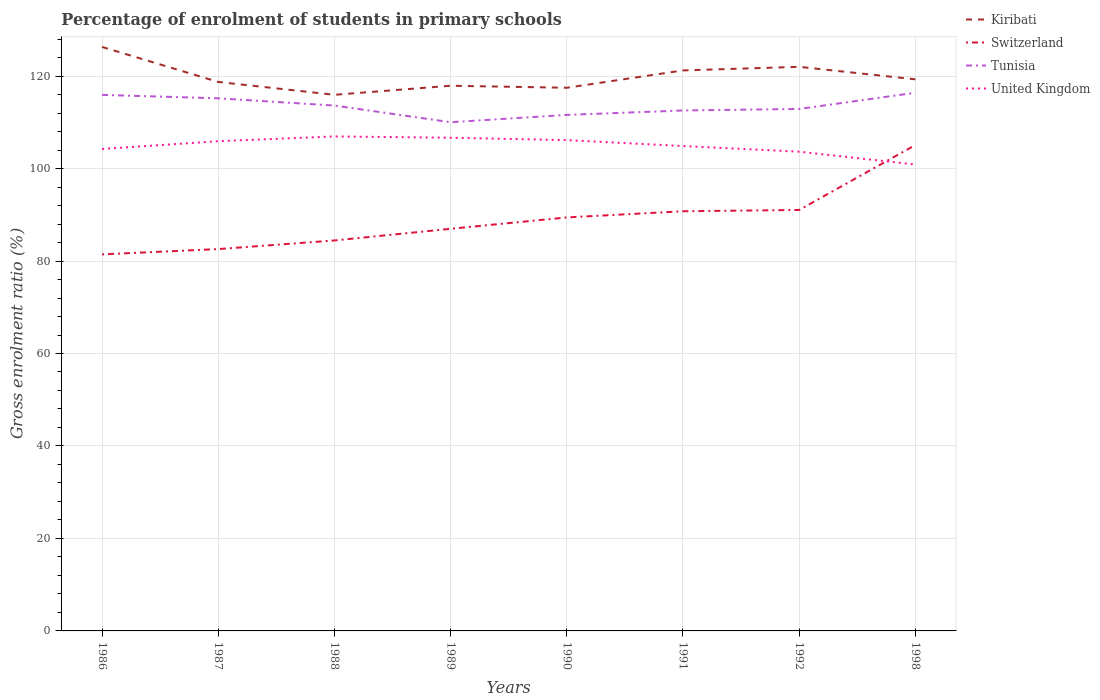Does the line corresponding to Kiribati intersect with the line corresponding to United Kingdom?
Offer a terse response. No. Is the number of lines equal to the number of legend labels?
Offer a terse response. Yes. Across all years, what is the maximum percentage of students enrolled in primary schools in United Kingdom?
Offer a terse response. 100.87. What is the total percentage of students enrolled in primary schools in Tunisia in the graph?
Your answer should be very brief. 5.91. What is the difference between the highest and the second highest percentage of students enrolled in primary schools in United Kingdom?
Ensure brevity in your answer.  6.07. How many years are there in the graph?
Keep it short and to the point. 8. What is the difference between two consecutive major ticks on the Y-axis?
Offer a terse response. 20. Are the values on the major ticks of Y-axis written in scientific E-notation?
Make the answer very short. No. Does the graph contain any zero values?
Your answer should be compact. No. Does the graph contain grids?
Provide a succinct answer. Yes. How are the legend labels stacked?
Give a very brief answer. Vertical. What is the title of the graph?
Your response must be concise. Percentage of enrolment of students in primary schools. What is the label or title of the X-axis?
Offer a very short reply. Years. What is the label or title of the Y-axis?
Your response must be concise. Gross enrolment ratio (%). What is the Gross enrolment ratio (%) of Kiribati in 1986?
Give a very brief answer. 126.3. What is the Gross enrolment ratio (%) of Switzerland in 1986?
Offer a very short reply. 81.44. What is the Gross enrolment ratio (%) of Tunisia in 1986?
Ensure brevity in your answer.  115.93. What is the Gross enrolment ratio (%) of United Kingdom in 1986?
Ensure brevity in your answer.  104.23. What is the Gross enrolment ratio (%) of Kiribati in 1987?
Your answer should be very brief. 118.73. What is the Gross enrolment ratio (%) in Switzerland in 1987?
Make the answer very short. 82.58. What is the Gross enrolment ratio (%) of Tunisia in 1987?
Ensure brevity in your answer.  115.19. What is the Gross enrolment ratio (%) of United Kingdom in 1987?
Provide a short and direct response. 105.91. What is the Gross enrolment ratio (%) of Kiribati in 1988?
Your response must be concise. 115.95. What is the Gross enrolment ratio (%) of Switzerland in 1988?
Your answer should be compact. 84.45. What is the Gross enrolment ratio (%) in Tunisia in 1988?
Keep it short and to the point. 113.62. What is the Gross enrolment ratio (%) of United Kingdom in 1988?
Offer a terse response. 106.94. What is the Gross enrolment ratio (%) in Kiribati in 1989?
Ensure brevity in your answer.  117.91. What is the Gross enrolment ratio (%) of Switzerland in 1989?
Offer a terse response. 86.97. What is the Gross enrolment ratio (%) in Tunisia in 1989?
Provide a short and direct response. 110.02. What is the Gross enrolment ratio (%) in United Kingdom in 1989?
Provide a short and direct response. 106.67. What is the Gross enrolment ratio (%) in Kiribati in 1990?
Your response must be concise. 117.47. What is the Gross enrolment ratio (%) in Switzerland in 1990?
Give a very brief answer. 89.43. What is the Gross enrolment ratio (%) of Tunisia in 1990?
Offer a terse response. 111.6. What is the Gross enrolment ratio (%) in United Kingdom in 1990?
Provide a succinct answer. 106.15. What is the Gross enrolment ratio (%) of Kiribati in 1991?
Your answer should be compact. 121.22. What is the Gross enrolment ratio (%) of Switzerland in 1991?
Your answer should be very brief. 90.76. What is the Gross enrolment ratio (%) of Tunisia in 1991?
Provide a short and direct response. 112.56. What is the Gross enrolment ratio (%) in United Kingdom in 1991?
Give a very brief answer. 104.87. What is the Gross enrolment ratio (%) in Kiribati in 1992?
Give a very brief answer. 122. What is the Gross enrolment ratio (%) of Switzerland in 1992?
Provide a short and direct response. 91.04. What is the Gross enrolment ratio (%) in Tunisia in 1992?
Provide a short and direct response. 112.89. What is the Gross enrolment ratio (%) of United Kingdom in 1992?
Ensure brevity in your answer.  103.65. What is the Gross enrolment ratio (%) of Kiribati in 1998?
Ensure brevity in your answer.  119.3. What is the Gross enrolment ratio (%) of Switzerland in 1998?
Your response must be concise. 105.09. What is the Gross enrolment ratio (%) in Tunisia in 1998?
Ensure brevity in your answer.  116.39. What is the Gross enrolment ratio (%) in United Kingdom in 1998?
Ensure brevity in your answer.  100.87. Across all years, what is the maximum Gross enrolment ratio (%) of Kiribati?
Your answer should be very brief. 126.3. Across all years, what is the maximum Gross enrolment ratio (%) in Switzerland?
Ensure brevity in your answer.  105.09. Across all years, what is the maximum Gross enrolment ratio (%) in Tunisia?
Ensure brevity in your answer.  116.39. Across all years, what is the maximum Gross enrolment ratio (%) of United Kingdom?
Your answer should be compact. 106.94. Across all years, what is the minimum Gross enrolment ratio (%) of Kiribati?
Make the answer very short. 115.95. Across all years, what is the minimum Gross enrolment ratio (%) of Switzerland?
Make the answer very short. 81.44. Across all years, what is the minimum Gross enrolment ratio (%) in Tunisia?
Keep it short and to the point. 110.02. Across all years, what is the minimum Gross enrolment ratio (%) of United Kingdom?
Your response must be concise. 100.87. What is the total Gross enrolment ratio (%) in Kiribati in the graph?
Keep it short and to the point. 958.88. What is the total Gross enrolment ratio (%) of Switzerland in the graph?
Provide a short and direct response. 711.76. What is the total Gross enrolment ratio (%) in Tunisia in the graph?
Your answer should be very brief. 908.21. What is the total Gross enrolment ratio (%) in United Kingdom in the graph?
Your answer should be compact. 839.3. What is the difference between the Gross enrolment ratio (%) of Kiribati in 1986 and that in 1987?
Your answer should be compact. 7.57. What is the difference between the Gross enrolment ratio (%) in Switzerland in 1986 and that in 1987?
Keep it short and to the point. -1.15. What is the difference between the Gross enrolment ratio (%) in Tunisia in 1986 and that in 1987?
Provide a short and direct response. 0.74. What is the difference between the Gross enrolment ratio (%) in United Kingdom in 1986 and that in 1987?
Offer a terse response. -1.68. What is the difference between the Gross enrolment ratio (%) in Kiribati in 1986 and that in 1988?
Offer a very short reply. 10.35. What is the difference between the Gross enrolment ratio (%) in Switzerland in 1986 and that in 1988?
Make the answer very short. -3.01. What is the difference between the Gross enrolment ratio (%) of Tunisia in 1986 and that in 1988?
Provide a short and direct response. 2.31. What is the difference between the Gross enrolment ratio (%) in United Kingdom in 1986 and that in 1988?
Provide a short and direct response. -2.71. What is the difference between the Gross enrolment ratio (%) in Kiribati in 1986 and that in 1989?
Keep it short and to the point. 8.39. What is the difference between the Gross enrolment ratio (%) of Switzerland in 1986 and that in 1989?
Provide a short and direct response. -5.53. What is the difference between the Gross enrolment ratio (%) of Tunisia in 1986 and that in 1989?
Your answer should be very brief. 5.91. What is the difference between the Gross enrolment ratio (%) of United Kingdom in 1986 and that in 1989?
Provide a short and direct response. -2.43. What is the difference between the Gross enrolment ratio (%) in Kiribati in 1986 and that in 1990?
Your response must be concise. 8.83. What is the difference between the Gross enrolment ratio (%) of Switzerland in 1986 and that in 1990?
Your answer should be compact. -7.99. What is the difference between the Gross enrolment ratio (%) of Tunisia in 1986 and that in 1990?
Your answer should be very brief. 4.33. What is the difference between the Gross enrolment ratio (%) in United Kingdom in 1986 and that in 1990?
Your answer should be compact. -1.92. What is the difference between the Gross enrolment ratio (%) of Kiribati in 1986 and that in 1991?
Give a very brief answer. 5.08. What is the difference between the Gross enrolment ratio (%) in Switzerland in 1986 and that in 1991?
Offer a very short reply. -9.32. What is the difference between the Gross enrolment ratio (%) in Tunisia in 1986 and that in 1991?
Your answer should be compact. 3.37. What is the difference between the Gross enrolment ratio (%) in United Kingdom in 1986 and that in 1991?
Your response must be concise. -0.63. What is the difference between the Gross enrolment ratio (%) of Kiribati in 1986 and that in 1992?
Your answer should be compact. 4.3. What is the difference between the Gross enrolment ratio (%) of Switzerland in 1986 and that in 1992?
Keep it short and to the point. -9.6. What is the difference between the Gross enrolment ratio (%) in Tunisia in 1986 and that in 1992?
Give a very brief answer. 3.04. What is the difference between the Gross enrolment ratio (%) of United Kingdom in 1986 and that in 1992?
Your response must be concise. 0.59. What is the difference between the Gross enrolment ratio (%) in Kiribati in 1986 and that in 1998?
Your response must be concise. 7. What is the difference between the Gross enrolment ratio (%) in Switzerland in 1986 and that in 1998?
Your answer should be very brief. -23.65. What is the difference between the Gross enrolment ratio (%) in Tunisia in 1986 and that in 1998?
Your answer should be compact. -0.46. What is the difference between the Gross enrolment ratio (%) in United Kingdom in 1986 and that in 1998?
Offer a terse response. 3.36. What is the difference between the Gross enrolment ratio (%) of Kiribati in 1987 and that in 1988?
Your answer should be compact. 2.78. What is the difference between the Gross enrolment ratio (%) in Switzerland in 1987 and that in 1988?
Provide a short and direct response. -1.86. What is the difference between the Gross enrolment ratio (%) of Tunisia in 1987 and that in 1988?
Provide a short and direct response. 1.57. What is the difference between the Gross enrolment ratio (%) in United Kingdom in 1987 and that in 1988?
Offer a terse response. -1.03. What is the difference between the Gross enrolment ratio (%) of Kiribati in 1987 and that in 1989?
Offer a terse response. 0.82. What is the difference between the Gross enrolment ratio (%) in Switzerland in 1987 and that in 1989?
Offer a terse response. -4.38. What is the difference between the Gross enrolment ratio (%) in Tunisia in 1987 and that in 1989?
Provide a succinct answer. 5.17. What is the difference between the Gross enrolment ratio (%) of United Kingdom in 1987 and that in 1989?
Provide a short and direct response. -0.75. What is the difference between the Gross enrolment ratio (%) in Kiribati in 1987 and that in 1990?
Your response must be concise. 1.26. What is the difference between the Gross enrolment ratio (%) in Switzerland in 1987 and that in 1990?
Keep it short and to the point. -6.85. What is the difference between the Gross enrolment ratio (%) in Tunisia in 1987 and that in 1990?
Your answer should be compact. 3.59. What is the difference between the Gross enrolment ratio (%) of United Kingdom in 1987 and that in 1990?
Provide a succinct answer. -0.24. What is the difference between the Gross enrolment ratio (%) of Kiribati in 1987 and that in 1991?
Provide a succinct answer. -2.49. What is the difference between the Gross enrolment ratio (%) of Switzerland in 1987 and that in 1991?
Provide a succinct answer. -8.18. What is the difference between the Gross enrolment ratio (%) in Tunisia in 1987 and that in 1991?
Keep it short and to the point. 2.63. What is the difference between the Gross enrolment ratio (%) in United Kingdom in 1987 and that in 1991?
Provide a short and direct response. 1.04. What is the difference between the Gross enrolment ratio (%) of Kiribati in 1987 and that in 1992?
Your answer should be very brief. -3.27. What is the difference between the Gross enrolment ratio (%) in Switzerland in 1987 and that in 1992?
Your answer should be very brief. -8.46. What is the difference between the Gross enrolment ratio (%) of Tunisia in 1987 and that in 1992?
Make the answer very short. 2.3. What is the difference between the Gross enrolment ratio (%) of United Kingdom in 1987 and that in 1992?
Make the answer very short. 2.27. What is the difference between the Gross enrolment ratio (%) of Kiribati in 1987 and that in 1998?
Offer a very short reply. -0.57. What is the difference between the Gross enrolment ratio (%) in Switzerland in 1987 and that in 1998?
Offer a terse response. -22.5. What is the difference between the Gross enrolment ratio (%) in Tunisia in 1987 and that in 1998?
Provide a succinct answer. -1.2. What is the difference between the Gross enrolment ratio (%) of United Kingdom in 1987 and that in 1998?
Provide a succinct answer. 5.04. What is the difference between the Gross enrolment ratio (%) of Kiribati in 1988 and that in 1989?
Offer a very short reply. -1.96. What is the difference between the Gross enrolment ratio (%) in Switzerland in 1988 and that in 1989?
Provide a short and direct response. -2.52. What is the difference between the Gross enrolment ratio (%) in Tunisia in 1988 and that in 1989?
Offer a very short reply. 3.6. What is the difference between the Gross enrolment ratio (%) in United Kingdom in 1988 and that in 1989?
Give a very brief answer. 0.28. What is the difference between the Gross enrolment ratio (%) in Kiribati in 1988 and that in 1990?
Give a very brief answer. -1.53. What is the difference between the Gross enrolment ratio (%) of Switzerland in 1988 and that in 1990?
Your answer should be very brief. -4.99. What is the difference between the Gross enrolment ratio (%) in Tunisia in 1988 and that in 1990?
Ensure brevity in your answer.  2.02. What is the difference between the Gross enrolment ratio (%) of United Kingdom in 1988 and that in 1990?
Your answer should be very brief. 0.79. What is the difference between the Gross enrolment ratio (%) of Kiribati in 1988 and that in 1991?
Provide a succinct answer. -5.27. What is the difference between the Gross enrolment ratio (%) of Switzerland in 1988 and that in 1991?
Your response must be concise. -6.31. What is the difference between the Gross enrolment ratio (%) of Tunisia in 1988 and that in 1991?
Provide a short and direct response. 1.06. What is the difference between the Gross enrolment ratio (%) in United Kingdom in 1988 and that in 1991?
Your answer should be very brief. 2.07. What is the difference between the Gross enrolment ratio (%) in Kiribati in 1988 and that in 1992?
Offer a terse response. -6.05. What is the difference between the Gross enrolment ratio (%) in Switzerland in 1988 and that in 1992?
Keep it short and to the point. -6.6. What is the difference between the Gross enrolment ratio (%) in Tunisia in 1988 and that in 1992?
Give a very brief answer. 0.73. What is the difference between the Gross enrolment ratio (%) of United Kingdom in 1988 and that in 1992?
Give a very brief answer. 3.3. What is the difference between the Gross enrolment ratio (%) in Kiribati in 1988 and that in 1998?
Ensure brevity in your answer.  -3.35. What is the difference between the Gross enrolment ratio (%) of Switzerland in 1988 and that in 1998?
Offer a very short reply. -20.64. What is the difference between the Gross enrolment ratio (%) of Tunisia in 1988 and that in 1998?
Offer a terse response. -2.77. What is the difference between the Gross enrolment ratio (%) of United Kingdom in 1988 and that in 1998?
Provide a succinct answer. 6.07. What is the difference between the Gross enrolment ratio (%) in Kiribati in 1989 and that in 1990?
Offer a very short reply. 0.43. What is the difference between the Gross enrolment ratio (%) of Switzerland in 1989 and that in 1990?
Your response must be concise. -2.47. What is the difference between the Gross enrolment ratio (%) of Tunisia in 1989 and that in 1990?
Your answer should be compact. -1.58. What is the difference between the Gross enrolment ratio (%) in United Kingdom in 1989 and that in 1990?
Provide a succinct answer. 0.52. What is the difference between the Gross enrolment ratio (%) of Kiribati in 1989 and that in 1991?
Your response must be concise. -3.32. What is the difference between the Gross enrolment ratio (%) of Switzerland in 1989 and that in 1991?
Make the answer very short. -3.79. What is the difference between the Gross enrolment ratio (%) in Tunisia in 1989 and that in 1991?
Ensure brevity in your answer.  -2.54. What is the difference between the Gross enrolment ratio (%) of United Kingdom in 1989 and that in 1991?
Your answer should be very brief. 1.8. What is the difference between the Gross enrolment ratio (%) of Kiribati in 1989 and that in 1992?
Provide a succinct answer. -4.09. What is the difference between the Gross enrolment ratio (%) of Switzerland in 1989 and that in 1992?
Offer a very short reply. -4.08. What is the difference between the Gross enrolment ratio (%) of Tunisia in 1989 and that in 1992?
Ensure brevity in your answer.  -2.87. What is the difference between the Gross enrolment ratio (%) in United Kingdom in 1989 and that in 1992?
Your response must be concise. 3.02. What is the difference between the Gross enrolment ratio (%) in Kiribati in 1989 and that in 1998?
Give a very brief answer. -1.39. What is the difference between the Gross enrolment ratio (%) in Switzerland in 1989 and that in 1998?
Offer a terse response. -18.12. What is the difference between the Gross enrolment ratio (%) in Tunisia in 1989 and that in 1998?
Give a very brief answer. -6.37. What is the difference between the Gross enrolment ratio (%) in United Kingdom in 1989 and that in 1998?
Ensure brevity in your answer.  5.8. What is the difference between the Gross enrolment ratio (%) in Kiribati in 1990 and that in 1991?
Provide a short and direct response. -3.75. What is the difference between the Gross enrolment ratio (%) of Switzerland in 1990 and that in 1991?
Your response must be concise. -1.33. What is the difference between the Gross enrolment ratio (%) of Tunisia in 1990 and that in 1991?
Ensure brevity in your answer.  -0.96. What is the difference between the Gross enrolment ratio (%) in United Kingdom in 1990 and that in 1991?
Your answer should be very brief. 1.28. What is the difference between the Gross enrolment ratio (%) of Kiribati in 1990 and that in 1992?
Make the answer very short. -4.53. What is the difference between the Gross enrolment ratio (%) in Switzerland in 1990 and that in 1992?
Your answer should be compact. -1.61. What is the difference between the Gross enrolment ratio (%) in Tunisia in 1990 and that in 1992?
Your response must be concise. -1.29. What is the difference between the Gross enrolment ratio (%) of United Kingdom in 1990 and that in 1992?
Provide a short and direct response. 2.5. What is the difference between the Gross enrolment ratio (%) of Kiribati in 1990 and that in 1998?
Provide a short and direct response. -1.82. What is the difference between the Gross enrolment ratio (%) in Switzerland in 1990 and that in 1998?
Your response must be concise. -15.65. What is the difference between the Gross enrolment ratio (%) in Tunisia in 1990 and that in 1998?
Give a very brief answer. -4.79. What is the difference between the Gross enrolment ratio (%) of United Kingdom in 1990 and that in 1998?
Provide a succinct answer. 5.28. What is the difference between the Gross enrolment ratio (%) in Kiribati in 1991 and that in 1992?
Your response must be concise. -0.78. What is the difference between the Gross enrolment ratio (%) of Switzerland in 1991 and that in 1992?
Make the answer very short. -0.28. What is the difference between the Gross enrolment ratio (%) in Tunisia in 1991 and that in 1992?
Your answer should be very brief. -0.33. What is the difference between the Gross enrolment ratio (%) of United Kingdom in 1991 and that in 1992?
Offer a terse response. 1.22. What is the difference between the Gross enrolment ratio (%) in Kiribati in 1991 and that in 1998?
Provide a short and direct response. 1.93. What is the difference between the Gross enrolment ratio (%) in Switzerland in 1991 and that in 1998?
Make the answer very short. -14.33. What is the difference between the Gross enrolment ratio (%) in Tunisia in 1991 and that in 1998?
Offer a very short reply. -3.83. What is the difference between the Gross enrolment ratio (%) of United Kingdom in 1991 and that in 1998?
Your answer should be very brief. 4. What is the difference between the Gross enrolment ratio (%) of Kiribati in 1992 and that in 1998?
Offer a terse response. 2.7. What is the difference between the Gross enrolment ratio (%) in Switzerland in 1992 and that in 1998?
Make the answer very short. -14.04. What is the difference between the Gross enrolment ratio (%) of Tunisia in 1992 and that in 1998?
Your answer should be compact. -3.5. What is the difference between the Gross enrolment ratio (%) in United Kingdom in 1992 and that in 1998?
Make the answer very short. 2.78. What is the difference between the Gross enrolment ratio (%) of Kiribati in 1986 and the Gross enrolment ratio (%) of Switzerland in 1987?
Give a very brief answer. 43.72. What is the difference between the Gross enrolment ratio (%) of Kiribati in 1986 and the Gross enrolment ratio (%) of Tunisia in 1987?
Give a very brief answer. 11.11. What is the difference between the Gross enrolment ratio (%) of Kiribati in 1986 and the Gross enrolment ratio (%) of United Kingdom in 1987?
Keep it short and to the point. 20.39. What is the difference between the Gross enrolment ratio (%) of Switzerland in 1986 and the Gross enrolment ratio (%) of Tunisia in 1987?
Make the answer very short. -33.75. What is the difference between the Gross enrolment ratio (%) in Switzerland in 1986 and the Gross enrolment ratio (%) in United Kingdom in 1987?
Offer a very short reply. -24.48. What is the difference between the Gross enrolment ratio (%) of Tunisia in 1986 and the Gross enrolment ratio (%) of United Kingdom in 1987?
Provide a short and direct response. 10.02. What is the difference between the Gross enrolment ratio (%) of Kiribati in 1986 and the Gross enrolment ratio (%) of Switzerland in 1988?
Provide a short and direct response. 41.85. What is the difference between the Gross enrolment ratio (%) in Kiribati in 1986 and the Gross enrolment ratio (%) in Tunisia in 1988?
Your response must be concise. 12.68. What is the difference between the Gross enrolment ratio (%) in Kiribati in 1986 and the Gross enrolment ratio (%) in United Kingdom in 1988?
Ensure brevity in your answer.  19.36. What is the difference between the Gross enrolment ratio (%) in Switzerland in 1986 and the Gross enrolment ratio (%) in Tunisia in 1988?
Your response must be concise. -32.18. What is the difference between the Gross enrolment ratio (%) of Switzerland in 1986 and the Gross enrolment ratio (%) of United Kingdom in 1988?
Your response must be concise. -25.51. What is the difference between the Gross enrolment ratio (%) of Tunisia in 1986 and the Gross enrolment ratio (%) of United Kingdom in 1988?
Your response must be concise. 8.99. What is the difference between the Gross enrolment ratio (%) of Kiribati in 1986 and the Gross enrolment ratio (%) of Switzerland in 1989?
Keep it short and to the point. 39.33. What is the difference between the Gross enrolment ratio (%) in Kiribati in 1986 and the Gross enrolment ratio (%) in Tunisia in 1989?
Offer a very short reply. 16.28. What is the difference between the Gross enrolment ratio (%) of Kiribati in 1986 and the Gross enrolment ratio (%) of United Kingdom in 1989?
Keep it short and to the point. 19.63. What is the difference between the Gross enrolment ratio (%) in Switzerland in 1986 and the Gross enrolment ratio (%) in Tunisia in 1989?
Your answer should be very brief. -28.58. What is the difference between the Gross enrolment ratio (%) in Switzerland in 1986 and the Gross enrolment ratio (%) in United Kingdom in 1989?
Offer a very short reply. -25.23. What is the difference between the Gross enrolment ratio (%) of Tunisia in 1986 and the Gross enrolment ratio (%) of United Kingdom in 1989?
Make the answer very short. 9.26. What is the difference between the Gross enrolment ratio (%) of Kiribati in 1986 and the Gross enrolment ratio (%) of Switzerland in 1990?
Offer a very short reply. 36.87. What is the difference between the Gross enrolment ratio (%) of Kiribati in 1986 and the Gross enrolment ratio (%) of Tunisia in 1990?
Keep it short and to the point. 14.7. What is the difference between the Gross enrolment ratio (%) in Kiribati in 1986 and the Gross enrolment ratio (%) in United Kingdom in 1990?
Make the answer very short. 20.15. What is the difference between the Gross enrolment ratio (%) of Switzerland in 1986 and the Gross enrolment ratio (%) of Tunisia in 1990?
Your answer should be compact. -30.16. What is the difference between the Gross enrolment ratio (%) in Switzerland in 1986 and the Gross enrolment ratio (%) in United Kingdom in 1990?
Make the answer very short. -24.71. What is the difference between the Gross enrolment ratio (%) of Tunisia in 1986 and the Gross enrolment ratio (%) of United Kingdom in 1990?
Make the answer very short. 9.78. What is the difference between the Gross enrolment ratio (%) of Kiribati in 1986 and the Gross enrolment ratio (%) of Switzerland in 1991?
Offer a very short reply. 35.54. What is the difference between the Gross enrolment ratio (%) of Kiribati in 1986 and the Gross enrolment ratio (%) of Tunisia in 1991?
Ensure brevity in your answer.  13.74. What is the difference between the Gross enrolment ratio (%) of Kiribati in 1986 and the Gross enrolment ratio (%) of United Kingdom in 1991?
Keep it short and to the point. 21.43. What is the difference between the Gross enrolment ratio (%) in Switzerland in 1986 and the Gross enrolment ratio (%) in Tunisia in 1991?
Your answer should be very brief. -31.12. What is the difference between the Gross enrolment ratio (%) of Switzerland in 1986 and the Gross enrolment ratio (%) of United Kingdom in 1991?
Your answer should be compact. -23.43. What is the difference between the Gross enrolment ratio (%) in Tunisia in 1986 and the Gross enrolment ratio (%) in United Kingdom in 1991?
Ensure brevity in your answer.  11.06. What is the difference between the Gross enrolment ratio (%) of Kiribati in 1986 and the Gross enrolment ratio (%) of Switzerland in 1992?
Offer a terse response. 35.26. What is the difference between the Gross enrolment ratio (%) of Kiribati in 1986 and the Gross enrolment ratio (%) of Tunisia in 1992?
Make the answer very short. 13.41. What is the difference between the Gross enrolment ratio (%) of Kiribati in 1986 and the Gross enrolment ratio (%) of United Kingdom in 1992?
Give a very brief answer. 22.65. What is the difference between the Gross enrolment ratio (%) of Switzerland in 1986 and the Gross enrolment ratio (%) of Tunisia in 1992?
Keep it short and to the point. -31.45. What is the difference between the Gross enrolment ratio (%) in Switzerland in 1986 and the Gross enrolment ratio (%) in United Kingdom in 1992?
Make the answer very short. -22.21. What is the difference between the Gross enrolment ratio (%) of Tunisia in 1986 and the Gross enrolment ratio (%) of United Kingdom in 1992?
Offer a terse response. 12.28. What is the difference between the Gross enrolment ratio (%) in Kiribati in 1986 and the Gross enrolment ratio (%) in Switzerland in 1998?
Ensure brevity in your answer.  21.21. What is the difference between the Gross enrolment ratio (%) in Kiribati in 1986 and the Gross enrolment ratio (%) in Tunisia in 1998?
Your answer should be very brief. 9.91. What is the difference between the Gross enrolment ratio (%) in Kiribati in 1986 and the Gross enrolment ratio (%) in United Kingdom in 1998?
Provide a short and direct response. 25.43. What is the difference between the Gross enrolment ratio (%) in Switzerland in 1986 and the Gross enrolment ratio (%) in Tunisia in 1998?
Provide a succinct answer. -34.95. What is the difference between the Gross enrolment ratio (%) in Switzerland in 1986 and the Gross enrolment ratio (%) in United Kingdom in 1998?
Make the answer very short. -19.43. What is the difference between the Gross enrolment ratio (%) of Tunisia in 1986 and the Gross enrolment ratio (%) of United Kingdom in 1998?
Give a very brief answer. 15.06. What is the difference between the Gross enrolment ratio (%) of Kiribati in 1987 and the Gross enrolment ratio (%) of Switzerland in 1988?
Make the answer very short. 34.28. What is the difference between the Gross enrolment ratio (%) in Kiribati in 1987 and the Gross enrolment ratio (%) in Tunisia in 1988?
Give a very brief answer. 5.11. What is the difference between the Gross enrolment ratio (%) in Kiribati in 1987 and the Gross enrolment ratio (%) in United Kingdom in 1988?
Keep it short and to the point. 11.79. What is the difference between the Gross enrolment ratio (%) in Switzerland in 1987 and the Gross enrolment ratio (%) in Tunisia in 1988?
Provide a short and direct response. -31.04. What is the difference between the Gross enrolment ratio (%) of Switzerland in 1987 and the Gross enrolment ratio (%) of United Kingdom in 1988?
Provide a short and direct response. -24.36. What is the difference between the Gross enrolment ratio (%) of Tunisia in 1987 and the Gross enrolment ratio (%) of United Kingdom in 1988?
Offer a terse response. 8.24. What is the difference between the Gross enrolment ratio (%) in Kiribati in 1987 and the Gross enrolment ratio (%) in Switzerland in 1989?
Provide a short and direct response. 31.76. What is the difference between the Gross enrolment ratio (%) in Kiribati in 1987 and the Gross enrolment ratio (%) in Tunisia in 1989?
Make the answer very short. 8.71. What is the difference between the Gross enrolment ratio (%) of Kiribati in 1987 and the Gross enrolment ratio (%) of United Kingdom in 1989?
Ensure brevity in your answer.  12.06. What is the difference between the Gross enrolment ratio (%) in Switzerland in 1987 and the Gross enrolment ratio (%) in Tunisia in 1989?
Ensure brevity in your answer.  -27.44. What is the difference between the Gross enrolment ratio (%) in Switzerland in 1987 and the Gross enrolment ratio (%) in United Kingdom in 1989?
Make the answer very short. -24.08. What is the difference between the Gross enrolment ratio (%) of Tunisia in 1987 and the Gross enrolment ratio (%) of United Kingdom in 1989?
Your answer should be compact. 8.52. What is the difference between the Gross enrolment ratio (%) of Kiribati in 1987 and the Gross enrolment ratio (%) of Switzerland in 1990?
Your answer should be compact. 29.3. What is the difference between the Gross enrolment ratio (%) of Kiribati in 1987 and the Gross enrolment ratio (%) of Tunisia in 1990?
Keep it short and to the point. 7.13. What is the difference between the Gross enrolment ratio (%) in Kiribati in 1987 and the Gross enrolment ratio (%) in United Kingdom in 1990?
Offer a very short reply. 12.58. What is the difference between the Gross enrolment ratio (%) of Switzerland in 1987 and the Gross enrolment ratio (%) of Tunisia in 1990?
Provide a succinct answer. -29.02. What is the difference between the Gross enrolment ratio (%) of Switzerland in 1987 and the Gross enrolment ratio (%) of United Kingdom in 1990?
Your answer should be very brief. -23.57. What is the difference between the Gross enrolment ratio (%) in Tunisia in 1987 and the Gross enrolment ratio (%) in United Kingdom in 1990?
Make the answer very short. 9.04. What is the difference between the Gross enrolment ratio (%) of Kiribati in 1987 and the Gross enrolment ratio (%) of Switzerland in 1991?
Give a very brief answer. 27.97. What is the difference between the Gross enrolment ratio (%) of Kiribati in 1987 and the Gross enrolment ratio (%) of Tunisia in 1991?
Offer a terse response. 6.17. What is the difference between the Gross enrolment ratio (%) in Kiribati in 1987 and the Gross enrolment ratio (%) in United Kingdom in 1991?
Your answer should be very brief. 13.86. What is the difference between the Gross enrolment ratio (%) of Switzerland in 1987 and the Gross enrolment ratio (%) of Tunisia in 1991?
Your answer should be very brief. -29.98. What is the difference between the Gross enrolment ratio (%) of Switzerland in 1987 and the Gross enrolment ratio (%) of United Kingdom in 1991?
Your response must be concise. -22.29. What is the difference between the Gross enrolment ratio (%) of Tunisia in 1987 and the Gross enrolment ratio (%) of United Kingdom in 1991?
Offer a terse response. 10.32. What is the difference between the Gross enrolment ratio (%) of Kiribati in 1987 and the Gross enrolment ratio (%) of Switzerland in 1992?
Make the answer very short. 27.69. What is the difference between the Gross enrolment ratio (%) in Kiribati in 1987 and the Gross enrolment ratio (%) in Tunisia in 1992?
Keep it short and to the point. 5.84. What is the difference between the Gross enrolment ratio (%) of Kiribati in 1987 and the Gross enrolment ratio (%) of United Kingdom in 1992?
Your answer should be very brief. 15.08. What is the difference between the Gross enrolment ratio (%) in Switzerland in 1987 and the Gross enrolment ratio (%) in Tunisia in 1992?
Your answer should be compact. -30.31. What is the difference between the Gross enrolment ratio (%) in Switzerland in 1987 and the Gross enrolment ratio (%) in United Kingdom in 1992?
Ensure brevity in your answer.  -21.06. What is the difference between the Gross enrolment ratio (%) in Tunisia in 1987 and the Gross enrolment ratio (%) in United Kingdom in 1992?
Your answer should be compact. 11.54. What is the difference between the Gross enrolment ratio (%) in Kiribati in 1987 and the Gross enrolment ratio (%) in Switzerland in 1998?
Keep it short and to the point. 13.64. What is the difference between the Gross enrolment ratio (%) in Kiribati in 1987 and the Gross enrolment ratio (%) in Tunisia in 1998?
Offer a very short reply. 2.34. What is the difference between the Gross enrolment ratio (%) of Kiribati in 1987 and the Gross enrolment ratio (%) of United Kingdom in 1998?
Ensure brevity in your answer.  17.86. What is the difference between the Gross enrolment ratio (%) of Switzerland in 1987 and the Gross enrolment ratio (%) of Tunisia in 1998?
Provide a short and direct response. -33.81. What is the difference between the Gross enrolment ratio (%) of Switzerland in 1987 and the Gross enrolment ratio (%) of United Kingdom in 1998?
Provide a succinct answer. -18.29. What is the difference between the Gross enrolment ratio (%) of Tunisia in 1987 and the Gross enrolment ratio (%) of United Kingdom in 1998?
Provide a short and direct response. 14.32. What is the difference between the Gross enrolment ratio (%) in Kiribati in 1988 and the Gross enrolment ratio (%) in Switzerland in 1989?
Your answer should be compact. 28.98. What is the difference between the Gross enrolment ratio (%) in Kiribati in 1988 and the Gross enrolment ratio (%) in Tunisia in 1989?
Make the answer very short. 5.93. What is the difference between the Gross enrolment ratio (%) in Kiribati in 1988 and the Gross enrolment ratio (%) in United Kingdom in 1989?
Your answer should be very brief. 9.28. What is the difference between the Gross enrolment ratio (%) in Switzerland in 1988 and the Gross enrolment ratio (%) in Tunisia in 1989?
Offer a very short reply. -25.57. What is the difference between the Gross enrolment ratio (%) in Switzerland in 1988 and the Gross enrolment ratio (%) in United Kingdom in 1989?
Make the answer very short. -22.22. What is the difference between the Gross enrolment ratio (%) in Tunisia in 1988 and the Gross enrolment ratio (%) in United Kingdom in 1989?
Your answer should be very brief. 6.96. What is the difference between the Gross enrolment ratio (%) of Kiribati in 1988 and the Gross enrolment ratio (%) of Switzerland in 1990?
Give a very brief answer. 26.52. What is the difference between the Gross enrolment ratio (%) in Kiribati in 1988 and the Gross enrolment ratio (%) in Tunisia in 1990?
Provide a short and direct response. 4.35. What is the difference between the Gross enrolment ratio (%) in Kiribati in 1988 and the Gross enrolment ratio (%) in United Kingdom in 1990?
Give a very brief answer. 9.8. What is the difference between the Gross enrolment ratio (%) of Switzerland in 1988 and the Gross enrolment ratio (%) of Tunisia in 1990?
Ensure brevity in your answer.  -27.16. What is the difference between the Gross enrolment ratio (%) of Switzerland in 1988 and the Gross enrolment ratio (%) of United Kingdom in 1990?
Provide a short and direct response. -21.7. What is the difference between the Gross enrolment ratio (%) of Tunisia in 1988 and the Gross enrolment ratio (%) of United Kingdom in 1990?
Your response must be concise. 7.47. What is the difference between the Gross enrolment ratio (%) in Kiribati in 1988 and the Gross enrolment ratio (%) in Switzerland in 1991?
Your answer should be very brief. 25.19. What is the difference between the Gross enrolment ratio (%) in Kiribati in 1988 and the Gross enrolment ratio (%) in Tunisia in 1991?
Offer a very short reply. 3.39. What is the difference between the Gross enrolment ratio (%) of Kiribati in 1988 and the Gross enrolment ratio (%) of United Kingdom in 1991?
Provide a short and direct response. 11.08. What is the difference between the Gross enrolment ratio (%) of Switzerland in 1988 and the Gross enrolment ratio (%) of Tunisia in 1991?
Offer a very short reply. -28.11. What is the difference between the Gross enrolment ratio (%) in Switzerland in 1988 and the Gross enrolment ratio (%) in United Kingdom in 1991?
Your answer should be compact. -20.42. What is the difference between the Gross enrolment ratio (%) in Tunisia in 1988 and the Gross enrolment ratio (%) in United Kingdom in 1991?
Provide a short and direct response. 8.75. What is the difference between the Gross enrolment ratio (%) of Kiribati in 1988 and the Gross enrolment ratio (%) of Switzerland in 1992?
Your answer should be compact. 24.91. What is the difference between the Gross enrolment ratio (%) in Kiribati in 1988 and the Gross enrolment ratio (%) in Tunisia in 1992?
Your response must be concise. 3.06. What is the difference between the Gross enrolment ratio (%) in Kiribati in 1988 and the Gross enrolment ratio (%) in United Kingdom in 1992?
Provide a succinct answer. 12.3. What is the difference between the Gross enrolment ratio (%) in Switzerland in 1988 and the Gross enrolment ratio (%) in Tunisia in 1992?
Ensure brevity in your answer.  -28.45. What is the difference between the Gross enrolment ratio (%) in Switzerland in 1988 and the Gross enrolment ratio (%) in United Kingdom in 1992?
Offer a terse response. -19.2. What is the difference between the Gross enrolment ratio (%) of Tunisia in 1988 and the Gross enrolment ratio (%) of United Kingdom in 1992?
Provide a short and direct response. 9.98. What is the difference between the Gross enrolment ratio (%) in Kiribati in 1988 and the Gross enrolment ratio (%) in Switzerland in 1998?
Make the answer very short. 10.86. What is the difference between the Gross enrolment ratio (%) of Kiribati in 1988 and the Gross enrolment ratio (%) of Tunisia in 1998?
Ensure brevity in your answer.  -0.44. What is the difference between the Gross enrolment ratio (%) of Kiribati in 1988 and the Gross enrolment ratio (%) of United Kingdom in 1998?
Make the answer very short. 15.08. What is the difference between the Gross enrolment ratio (%) in Switzerland in 1988 and the Gross enrolment ratio (%) in Tunisia in 1998?
Ensure brevity in your answer.  -31.95. What is the difference between the Gross enrolment ratio (%) of Switzerland in 1988 and the Gross enrolment ratio (%) of United Kingdom in 1998?
Make the answer very short. -16.42. What is the difference between the Gross enrolment ratio (%) of Tunisia in 1988 and the Gross enrolment ratio (%) of United Kingdom in 1998?
Your response must be concise. 12.75. What is the difference between the Gross enrolment ratio (%) in Kiribati in 1989 and the Gross enrolment ratio (%) in Switzerland in 1990?
Ensure brevity in your answer.  28.47. What is the difference between the Gross enrolment ratio (%) in Kiribati in 1989 and the Gross enrolment ratio (%) in Tunisia in 1990?
Your answer should be compact. 6.3. What is the difference between the Gross enrolment ratio (%) of Kiribati in 1989 and the Gross enrolment ratio (%) of United Kingdom in 1990?
Your answer should be very brief. 11.76. What is the difference between the Gross enrolment ratio (%) in Switzerland in 1989 and the Gross enrolment ratio (%) in Tunisia in 1990?
Offer a terse response. -24.64. What is the difference between the Gross enrolment ratio (%) in Switzerland in 1989 and the Gross enrolment ratio (%) in United Kingdom in 1990?
Your response must be concise. -19.18. What is the difference between the Gross enrolment ratio (%) in Tunisia in 1989 and the Gross enrolment ratio (%) in United Kingdom in 1990?
Give a very brief answer. 3.87. What is the difference between the Gross enrolment ratio (%) in Kiribati in 1989 and the Gross enrolment ratio (%) in Switzerland in 1991?
Make the answer very short. 27.15. What is the difference between the Gross enrolment ratio (%) in Kiribati in 1989 and the Gross enrolment ratio (%) in Tunisia in 1991?
Offer a very short reply. 5.35. What is the difference between the Gross enrolment ratio (%) of Kiribati in 1989 and the Gross enrolment ratio (%) of United Kingdom in 1991?
Make the answer very short. 13.04. What is the difference between the Gross enrolment ratio (%) in Switzerland in 1989 and the Gross enrolment ratio (%) in Tunisia in 1991?
Your answer should be very brief. -25.59. What is the difference between the Gross enrolment ratio (%) of Switzerland in 1989 and the Gross enrolment ratio (%) of United Kingdom in 1991?
Your response must be concise. -17.9. What is the difference between the Gross enrolment ratio (%) of Tunisia in 1989 and the Gross enrolment ratio (%) of United Kingdom in 1991?
Offer a very short reply. 5.15. What is the difference between the Gross enrolment ratio (%) in Kiribati in 1989 and the Gross enrolment ratio (%) in Switzerland in 1992?
Ensure brevity in your answer.  26.86. What is the difference between the Gross enrolment ratio (%) of Kiribati in 1989 and the Gross enrolment ratio (%) of Tunisia in 1992?
Keep it short and to the point. 5.02. What is the difference between the Gross enrolment ratio (%) of Kiribati in 1989 and the Gross enrolment ratio (%) of United Kingdom in 1992?
Provide a succinct answer. 14.26. What is the difference between the Gross enrolment ratio (%) of Switzerland in 1989 and the Gross enrolment ratio (%) of Tunisia in 1992?
Your answer should be very brief. -25.92. What is the difference between the Gross enrolment ratio (%) of Switzerland in 1989 and the Gross enrolment ratio (%) of United Kingdom in 1992?
Keep it short and to the point. -16.68. What is the difference between the Gross enrolment ratio (%) of Tunisia in 1989 and the Gross enrolment ratio (%) of United Kingdom in 1992?
Your answer should be compact. 6.37. What is the difference between the Gross enrolment ratio (%) of Kiribati in 1989 and the Gross enrolment ratio (%) of Switzerland in 1998?
Your answer should be compact. 12.82. What is the difference between the Gross enrolment ratio (%) of Kiribati in 1989 and the Gross enrolment ratio (%) of Tunisia in 1998?
Provide a succinct answer. 1.51. What is the difference between the Gross enrolment ratio (%) of Kiribati in 1989 and the Gross enrolment ratio (%) of United Kingdom in 1998?
Your answer should be compact. 17.04. What is the difference between the Gross enrolment ratio (%) of Switzerland in 1989 and the Gross enrolment ratio (%) of Tunisia in 1998?
Your answer should be very brief. -29.42. What is the difference between the Gross enrolment ratio (%) of Switzerland in 1989 and the Gross enrolment ratio (%) of United Kingdom in 1998?
Your answer should be compact. -13.9. What is the difference between the Gross enrolment ratio (%) of Tunisia in 1989 and the Gross enrolment ratio (%) of United Kingdom in 1998?
Make the answer very short. 9.15. What is the difference between the Gross enrolment ratio (%) in Kiribati in 1990 and the Gross enrolment ratio (%) in Switzerland in 1991?
Ensure brevity in your answer.  26.71. What is the difference between the Gross enrolment ratio (%) of Kiribati in 1990 and the Gross enrolment ratio (%) of Tunisia in 1991?
Provide a succinct answer. 4.92. What is the difference between the Gross enrolment ratio (%) of Kiribati in 1990 and the Gross enrolment ratio (%) of United Kingdom in 1991?
Your response must be concise. 12.61. What is the difference between the Gross enrolment ratio (%) of Switzerland in 1990 and the Gross enrolment ratio (%) of Tunisia in 1991?
Give a very brief answer. -23.13. What is the difference between the Gross enrolment ratio (%) in Switzerland in 1990 and the Gross enrolment ratio (%) in United Kingdom in 1991?
Offer a terse response. -15.44. What is the difference between the Gross enrolment ratio (%) of Tunisia in 1990 and the Gross enrolment ratio (%) of United Kingdom in 1991?
Keep it short and to the point. 6.73. What is the difference between the Gross enrolment ratio (%) in Kiribati in 1990 and the Gross enrolment ratio (%) in Switzerland in 1992?
Your response must be concise. 26.43. What is the difference between the Gross enrolment ratio (%) of Kiribati in 1990 and the Gross enrolment ratio (%) of Tunisia in 1992?
Ensure brevity in your answer.  4.58. What is the difference between the Gross enrolment ratio (%) in Kiribati in 1990 and the Gross enrolment ratio (%) in United Kingdom in 1992?
Your response must be concise. 13.83. What is the difference between the Gross enrolment ratio (%) in Switzerland in 1990 and the Gross enrolment ratio (%) in Tunisia in 1992?
Your answer should be very brief. -23.46. What is the difference between the Gross enrolment ratio (%) of Switzerland in 1990 and the Gross enrolment ratio (%) of United Kingdom in 1992?
Offer a terse response. -14.21. What is the difference between the Gross enrolment ratio (%) of Tunisia in 1990 and the Gross enrolment ratio (%) of United Kingdom in 1992?
Offer a terse response. 7.96. What is the difference between the Gross enrolment ratio (%) of Kiribati in 1990 and the Gross enrolment ratio (%) of Switzerland in 1998?
Offer a very short reply. 12.39. What is the difference between the Gross enrolment ratio (%) in Kiribati in 1990 and the Gross enrolment ratio (%) in Tunisia in 1998?
Ensure brevity in your answer.  1.08. What is the difference between the Gross enrolment ratio (%) in Kiribati in 1990 and the Gross enrolment ratio (%) in United Kingdom in 1998?
Ensure brevity in your answer.  16.6. What is the difference between the Gross enrolment ratio (%) of Switzerland in 1990 and the Gross enrolment ratio (%) of Tunisia in 1998?
Ensure brevity in your answer.  -26.96. What is the difference between the Gross enrolment ratio (%) of Switzerland in 1990 and the Gross enrolment ratio (%) of United Kingdom in 1998?
Keep it short and to the point. -11.44. What is the difference between the Gross enrolment ratio (%) of Tunisia in 1990 and the Gross enrolment ratio (%) of United Kingdom in 1998?
Provide a short and direct response. 10.73. What is the difference between the Gross enrolment ratio (%) in Kiribati in 1991 and the Gross enrolment ratio (%) in Switzerland in 1992?
Provide a succinct answer. 30.18. What is the difference between the Gross enrolment ratio (%) of Kiribati in 1991 and the Gross enrolment ratio (%) of Tunisia in 1992?
Give a very brief answer. 8.33. What is the difference between the Gross enrolment ratio (%) of Kiribati in 1991 and the Gross enrolment ratio (%) of United Kingdom in 1992?
Give a very brief answer. 17.58. What is the difference between the Gross enrolment ratio (%) in Switzerland in 1991 and the Gross enrolment ratio (%) in Tunisia in 1992?
Keep it short and to the point. -22.13. What is the difference between the Gross enrolment ratio (%) of Switzerland in 1991 and the Gross enrolment ratio (%) of United Kingdom in 1992?
Give a very brief answer. -12.89. What is the difference between the Gross enrolment ratio (%) of Tunisia in 1991 and the Gross enrolment ratio (%) of United Kingdom in 1992?
Your response must be concise. 8.91. What is the difference between the Gross enrolment ratio (%) in Kiribati in 1991 and the Gross enrolment ratio (%) in Switzerland in 1998?
Offer a very short reply. 16.14. What is the difference between the Gross enrolment ratio (%) in Kiribati in 1991 and the Gross enrolment ratio (%) in Tunisia in 1998?
Your answer should be very brief. 4.83. What is the difference between the Gross enrolment ratio (%) of Kiribati in 1991 and the Gross enrolment ratio (%) of United Kingdom in 1998?
Offer a terse response. 20.35. What is the difference between the Gross enrolment ratio (%) of Switzerland in 1991 and the Gross enrolment ratio (%) of Tunisia in 1998?
Give a very brief answer. -25.63. What is the difference between the Gross enrolment ratio (%) in Switzerland in 1991 and the Gross enrolment ratio (%) in United Kingdom in 1998?
Keep it short and to the point. -10.11. What is the difference between the Gross enrolment ratio (%) in Tunisia in 1991 and the Gross enrolment ratio (%) in United Kingdom in 1998?
Provide a short and direct response. 11.69. What is the difference between the Gross enrolment ratio (%) of Kiribati in 1992 and the Gross enrolment ratio (%) of Switzerland in 1998?
Your answer should be very brief. 16.91. What is the difference between the Gross enrolment ratio (%) in Kiribati in 1992 and the Gross enrolment ratio (%) in Tunisia in 1998?
Offer a terse response. 5.61. What is the difference between the Gross enrolment ratio (%) in Kiribati in 1992 and the Gross enrolment ratio (%) in United Kingdom in 1998?
Your response must be concise. 21.13. What is the difference between the Gross enrolment ratio (%) of Switzerland in 1992 and the Gross enrolment ratio (%) of Tunisia in 1998?
Make the answer very short. -25.35. What is the difference between the Gross enrolment ratio (%) of Switzerland in 1992 and the Gross enrolment ratio (%) of United Kingdom in 1998?
Your answer should be compact. -9.83. What is the difference between the Gross enrolment ratio (%) of Tunisia in 1992 and the Gross enrolment ratio (%) of United Kingdom in 1998?
Offer a very short reply. 12.02. What is the average Gross enrolment ratio (%) in Kiribati per year?
Make the answer very short. 119.86. What is the average Gross enrolment ratio (%) of Switzerland per year?
Make the answer very short. 88.97. What is the average Gross enrolment ratio (%) in Tunisia per year?
Offer a very short reply. 113.53. What is the average Gross enrolment ratio (%) in United Kingdom per year?
Your answer should be very brief. 104.91. In the year 1986, what is the difference between the Gross enrolment ratio (%) in Kiribati and Gross enrolment ratio (%) in Switzerland?
Give a very brief answer. 44.86. In the year 1986, what is the difference between the Gross enrolment ratio (%) of Kiribati and Gross enrolment ratio (%) of Tunisia?
Your response must be concise. 10.37. In the year 1986, what is the difference between the Gross enrolment ratio (%) of Kiribati and Gross enrolment ratio (%) of United Kingdom?
Ensure brevity in your answer.  22.07. In the year 1986, what is the difference between the Gross enrolment ratio (%) in Switzerland and Gross enrolment ratio (%) in Tunisia?
Keep it short and to the point. -34.49. In the year 1986, what is the difference between the Gross enrolment ratio (%) in Switzerland and Gross enrolment ratio (%) in United Kingdom?
Ensure brevity in your answer.  -22.8. In the year 1986, what is the difference between the Gross enrolment ratio (%) of Tunisia and Gross enrolment ratio (%) of United Kingdom?
Provide a succinct answer. 11.7. In the year 1987, what is the difference between the Gross enrolment ratio (%) in Kiribati and Gross enrolment ratio (%) in Switzerland?
Offer a terse response. 36.15. In the year 1987, what is the difference between the Gross enrolment ratio (%) of Kiribati and Gross enrolment ratio (%) of Tunisia?
Keep it short and to the point. 3.54. In the year 1987, what is the difference between the Gross enrolment ratio (%) in Kiribati and Gross enrolment ratio (%) in United Kingdom?
Ensure brevity in your answer.  12.82. In the year 1987, what is the difference between the Gross enrolment ratio (%) in Switzerland and Gross enrolment ratio (%) in Tunisia?
Your answer should be very brief. -32.61. In the year 1987, what is the difference between the Gross enrolment ratio (%) of Switzerland and Gross enrolment ratio (%) of United Kingdom?
Offer a very short reply. -23.33. In the year 1987, what is the difference between the Gross enrolment ratio (%) of Tunisia and Gross enrolment ratio (%) of United Kingdom?
Make the answer very short. 9.27. In the year 1988, what is the difference between the Gross enrolment ratio (%) of Kiribati and Gross enrolment ratio (%) of Switzerland?
Offer a very short reply. 31.5. In the year 1988, what is the difference between the Gross enrolment ratio (%) of Kiribati and Gross enrolment ratio (%) of Tunisia?
Keep it short and to the point. 2.33. In the year 1988, what is the difference between the Gross enrolment ratio (%) in Kiribati and Gross enrolment ratio (%) in United Kingdom?
Provide a short and direct response. 9. In the year 1988, what is the difference between the Gross enrolment ratio (%) of Switzerland and Gross enrolment ratio (%) of Tunisia?
Your answer should be very brief. -29.18. In the year 1988, what is the difference between the Gross enrolment ratio (%) in Switzerland and Gross enrolment ratio (%) in United Kingdom?
Give a very brief answer. -22.5. In the year 1988, what is the difference between the Gross enrolment ratio (%) in Tunisia and Gross enrolment ratio (%) in United Kingdom?
Provide a succinct answer. 6.68. In the year 1989, what is the difference between the Gross enrolment ratio (%) of Kiribati and Gross enrolment ratio (%) of Switzerland?
Your answer should be very brief. 30.94. In the year 1989, what is the difference between the Gross enrolment ratio (%) of Kiribati and Gross enrolment ratio (%) of Tunisia?
Give a very brief answer. 7.89. In the year 1989, what is the difference between the Gross enrolment ratio (%) in Kiribati and Gross enrolment ratio (%) in United Kingdom?
Your answer should be compact. 11.24. In the year 1989, what is the difference between the Gross enrolment ratio (%) of Switzerland and Gross enrolment ratio (%) of Tunisia?
Give a very brief answer. -23.05. In the year 1989, what is the difference between the Gross enrolment ratio (%) in Switzerland and Gross enrolment ratio (%) in United Kingdom?
Your answer should be compact. -19.7. In the year 1989, what is the difference between the Gross enrolment ratio (%) in Tunisia and Gross enrolment ratio (%) in United Kingdom?
Provide a short and direct response. 3.35. In the year 1990, what is the difference between the Gross enrolment ratio (%) in Kiribati and Gross enrolment ratio (%) in Switzerland?
Your answer should be compact. 28.04. In the year 1990, what is the difference between the Gross enrolment ratio (%) of Kiribati and Gross enrolment ratio (%) of Tunisia?
Provide a succinct answer. 5.87. In the year 1990, what is the difference between the Gross enrolment ratio (%) of Kiribati and Gross enrolment ratio (%) of United Kingdom?
Provide a succinct answer. 11.32. In the year 1990, what is the difference between the Gross enrolment ratio (%) of Switzerland and Gross enrolment ratio (%) of Tunisia?
Offer a very short reply. -22.17. In the year 1990, what is the difference between the Gross enrolment ratio (%) in Switzerland and Gross enrolment ratio (%) in United Kingdom?
Your response must be concise. -16.72. In the year 1990, what is the difference between the Gross enrolment ratio (%) in Tunisia and Gross enrolment ratio (%) in United Kingdom?
Offer a terse response. 5.45. In the year 1991, what is the difference between the Gross enrolment ratio (%) of Kiribati and Gross enrolment ratio (%) of Switzerland?
Offer a very short reply. 30.46. In the year 1991, what is the difference between the Gross enrolment ratio (%) in Kiribati and Gross enrolment ratio (%) in Tunisia?
Offer a very short reply. 8.66. In the year 1991, what is the difference between the Gross enrolment ratio (%) of Kiribati and Gross enrolment ratio (%) of United Kingdom?
Your answer should be compact. 16.35. In the year 1991, what is the difference between the Gross enrolment ratio (%) of Switzerland and Gross enrolment ratio (%) of Tunisia?
Offer a very short reply. -21.8. In the year 1991, what is the difference between the Gross enrolment ratio (%) in Switzerland and Gross enrolment ratio (%) in United Kingdom?
Your answer should be compact. -14.11. In the year 1991, what is the difference between the Gross enrolment ratio (%) of Tunisia and Gross enrolment ratio (%) of United Kingdom?
Offer a very short reply. 7.69. In the year 1992, what is the difference between the Gross enrolment ratio (%) in Kiribati and Gross enrolment ratio (%) in Switzerland?
Keep it short and to the point. 30.96. In the year 1992, what is the difference between the Gross enrolment ratio (%) in Kiribati and Gross enrolment ratio (%) in Tunisia?
Provide a succinct answer. 9.11. In the year 1992, what is the difference between the Gross enrolment ratio (%) in Kiribati and Gross enrolment ratio (%) in United Kingdom?
Your answer should be very brief. 18.35. In the year 1992, what is the difference between the Gross enrolment ratio (%) in Switzerland and Gross enrolment ratio (%) in Tunisia?
Your response must be concise. -21.85. In the year 1992, what is the difference between the Gross enrolment ratio (%) in Switzerland and Gross enrolment ratio (%) in United Kingdom?
Your answer should be very brief. -12.6. In the year 1992, what is the difference between the Gross enrolment ratio (%) of Tunisia and Gross enrolment ratio (%) of United Kingdom?
Provide a succinct answer. 9.24. In the year 1998, what is the difference between the Gross enrolment ratio (%) in Kiribati and Gross enrolment ratio (%) in Switzerland?
Your answer should be compact. 14.21. In the year 1998, what is the difference between the Gross enrolment ratio (%) in Kiribati and Gross enrolment ratio (%) in Tunisia?
Give a very brief answer. 2.91. In the year 1998, what is the difference between the Gross enrolment ratio (%) of Kiribati and Gross enrolment ratio (%) of United Kingdom?
Provide a succinct answer. 18.43. In the year 1998, what is the difference between the Gross enrolment ratio (%) of Switzerland and Gross enrolment ratio (%) of Tunisia?
Make the answer very short. -11.3. In the year 1998, what is the difference between the Gross enrolment ratio (%) of Switzerland and Gross enrolment ratio (%) of United Kingdom?
Your response must be concise. 4.22. In the year 1998, what is the difference between the Gross enrolment ratio (%) in Tunisia and Gross enrolment ratio (%) in United Kingdom?
Offer a terse response. 15.52. What is the ratio of the Gross enrolment ratio (%) of Kiribati in 1986 to that in 1987?
Offer a terse response. 1.06. What is the ratio of the Gross enrolment ratio (%) of Switzerland in 1986 to that in 1987?
Your answer should be very brief. 0.99. What is the ratio of the Gross enrolment ratio (%) of Tunisia in 1986 to that in 1987?
Your answer should be compact. 1.01. What is the ratio of the Gross enrolment ratio (%) of United Kingdom in 1986 to that in 1987?
Offer a terse response. 0.98. What is the ratio of the Gross enrolment ratio (%) in Kiribati in 1986 to that in 1988?
Keep it short and to the point. 1.09. What is the ratio of the Gross enrolment ratio (%) in Switzerland in 1986 to that in 1988?
Ensure brevity in your answer.  0.96. What is the ratio of the Gross enrolment ratio (%) of Tunisia in 1986 to that in 1988?
Your answer should be compact. 1.02. What is the ratio of the Gross enrolment ratio (%) in United Kingdom in 1986 to that in 1988?
Your answer should be very brief. 0.97. What is the ratio of the Gross enrolment ratio (%) of Kiribati in 1986 to that in 1989?
Give a very brief answer. 1.07. What is the ratio of the Gross enrolment ratio (%) of Switzerland in 1986 to that in 1989?
Offer a terse response. 0.94. What is the ratio of the Gross enrolment ratio (%) of Tunisia in 1986 to that in 1989?
Offer a very short reply. 1.05. What is the ratio of the Gross enrolment ratio (%) in United Kingdom in 1986 to that in 1989?
Your response must be concise. 0.98. What is the ratio of the Gross enrolment ratio (%) of Kiribati in 1986 to that in 1990?
Your response must be concise. 1.08. What is the ratio of the Gross enrolment ratio (%) in Switzerland in 1986 to that in 1990?
Provide a succinct answer. 0.91. What is the ratio of the Gross enrolment ratio (%) in Tunisia in 1986 to that in 1990?
Make the answer very short. 1.04. What is the ratio of the Gross enrolment ratio (%) in United Kingdom in 1986 to that in 1990?
Ensure brevity in your answer.  0.98. What is the ratio of the Gross enrolment ratio (%) in Kiribati in 1986 to that in 1991?
Ensure brevity in your answer.  1.04. What is the ratio of the Gross enrolment ratio (%) in Switzerland in 1986 to that in 1991?
Provide a succinct answer. 0.9. What is the ratio of the Gross enrolment ratio (%) in Tunisia in 1986 to that in 1991?
Your answer should be very brief. 1.03. What is the ratio of the Gross enrolment ratio (%) in United Kingdom in 1986 to that in 1991?
Your response must be concise. 0.99. What is the ratio of the Gross enrolment ratio (%) of Kiribati in 1986 to that in 1992?
Provide a short and direct response. 1.04. What is the ratio of the Gross enrolment ratio (%) of Switzerland in 1986 to that in 1992?
Offer a terse response. 0.89. What is the ratio of the Gross enrolment ratio (%) in Tunisia in 1986 to that in 1992?
Provide a short and direct response. 1.03. What is the ratio of the Gross enrolment ratio (%) in United Kingdom in 1986 to that in 1992?
Provide a succinct answer. 1.01. What is the ratio of the Gross enrolment ratio (%) in Kiribati in 1986 to that in 1998?
Your answer should be very brief. 1.06. What is the ratio of the Gross enrolment ratio (%) in Switzerland in 1986 to that in 1998?
Offer a very short reply. 0.78. What is the ratio of the Gross enrolment ratio (%) of Tunisia in 1986 to that in 1998?
Offer a terse response. 1. What is the ratio of the Gross enrolment ratio (%) of United Kingdom in 1986 to that in 1998?
Your answer should be very brief. 1.03. What is the ratio of the Gross enrolment ratio (%) of Kiribati in 1987 to that in 1988?
Your answer should be very brief. 1.02. What is the ratio of the Gross enrolment ratio (%) in Switzerland in 1987 to that in 1988?
Provide a succinct answer. 0.98. What is the ratio of the Gross enrolment ratio (%) in Tunisia in 1987 to that in 1988?
Your answer should be very brief. 1.01. What is the ratio of the Gross enrolment ratio (%) in Kiribati in 1987 to that in 1989?
Your answer should be very brief. 1.01. What is the ratio of the Gross enrolment ratio (%) of Switzerland in 1987 to that in 1989?
Give a very brief answer. 0.95. What is the ratio of the Gross enrolment ratio (%) of Tunisia in 1987 to that in 1989?
Make the answer very short. 1.05. What is the ratio of the Gross enrolment ratio (%) of Kiribati in 1987 to that in 1990?
Your response must be concise. 1.01. What is the ratio of the Gross enrolment ratio (%) of Switzerland in 1987 to that in 1990?
Give a very brief answer. 0.92. What is the ratio of the Gross enrolment ratio (%) in Tunisia in 1987 to that in 1990?
Offer a very short reply. 1.03. What is the ratio of the Gross enrolment ratio (%) in Kiribati in 1987 to that in 1991?
Provide a short and direct response. 0.98. What is the ratio of the Gross enrolment ratio (%) of Switzerland in 1987 to that in 1991?
Offer a very short reply. 0.91. What is the ratio of the Gross enrolment ratio (%) of Tunisia in 1987 to that in 1991?
Keep it short and to the point. 1.02. What is the ratio of the Gross enrolment ratio (%) of United Kingdom in 1987 to that in 1991?
Your answer should be compact. 1.01. What is the ratio of the Gross enrolment ratio (%) of Kiribati in 1987 to that in 1992?
Your response must be concise. 0.97. What is the ratio of the Gross enrolment ratio (%) in Switzerland in 1987 to that in 1992?
Provide a succinct answer. 0.91. What is the ratio of the Gross enrolment ratio (%) in Tunisia in 1987 to that in 1992?
Provide a short and direct response. 1.02. What is the ratio of the Gross enrolment ratio (%) of United Kingdom in 1987 to that in 1992?
Your answer should be compact. 1.02. What is the ratio of the Gross enrolment ratio (%) of Kiribati in 1987 to that in 1998?
Offer a terse response. 1. What is the ratio of the Gross enrolment ratio (%) in Switzerland in 1987 to that in 1998?
Ensure brevity in your answer.  0.79. What is the ratio of the Gross enrolment ratio (%) in Tunisia in 1987 to that in 1998?
Offer a terse response. 0.99. What is the ratio of the Gross enrolment ratio (%) in United Kingdom in 1987 to that in 1998?
Your answer should be compact. 1.05. What is the ratio of the Gross enrolment ratio (%) of Kiribati in 1988 to that in 1989?
Offer a very short reply. 0.98. What is the ratio of the Gross enrolment ratio (%) of Switzerland in 1988 to that in 1989?
Make the answer very short. 0.97. What is the ratio of the Gross enrolment ratio (%) in Tunisia in 1988 to that in 1989?
Provide a short and direct response. 1.03. What is the ratio of the Gross enrolment ratio (%) of United Kingdom in 1988 to that in 1989?
Offer a very short reply. 1. What is the ratio of the Gross enrolment ratio (%) in Switzerland in 1988 to that in 1990?
Ensure brevity in your answer.  0.94. What is the ratio of the Gross enrolment ratio (%) of Tunisia in 1988 to that in 1990?
Provide a short and direct response. 1.02. What is the ratio of the Gross enrolment ratio (%) in United Kingdom in 1988 to that in 1990?
Make the answer very short. 1.01. What is the ratio of the Gross enrolment ratio (%) in Kiribati in 1988 to that in 1991?
Make the answer very short. 0.96. What is the ratio of the Gross enrolment ratio (%) in Switzerland in 1988 to that in 1991?
Offer a very short reply. 0.93. What is the ratio of the Gross enrolment ratio (%) of Tunisia in 1988 to that in 1991?
Offer a very short reply. 1.01. What is the ratio of the Gross enrolment ratio (%) of United Kingdom in 1988 to that in 1991?
Ensure brevity in your answer.  1.02. What is the ratio of the Gross enrolment ratio (%) of Kiribati in 1988 to that in 1992?
Your response must be concise. 0.95. What is the ratio of the Gross enrolment ratio (%) in Switzerland in 1988 to that in 1992?
Keep it short and to the point. 0.93. What is the ratio of the Gross enrolment ratio (%) in United Kingdom in 1988 to that in 1992?
Provide a short and direct response. 1.03. What is the ratio of the Gross enrolment ratio (%) in Kiribati in 1988 to that in 1998?
Your response must be concise. 0.97. What is the ratio of the Gross enrolment ratio (%) in Switzerland in 1988 to that in 1998?
Keep it short and to the point. 0.8. What is the ratio of the Gross enrolment ratio (%) in Tunisia in 1988 to that in 1998?
Make the answer very short. 0.98. What is the ratio of the Gross enrolment ratio (%) of United Kingdom in 1988 to that in 1998?
Give a very brief answer. 1.06. What is the ratio of the Gross enrolment ratio (%) of Kiribati in 1989 to that in 1990?
Ensure brevity in your answer.  1. What is the ratio of the Gross enrolment ratio (%) of Switzerland in 1989 to that in 1990?
Offer a terse response. 0.97. What is the ratio of the Gross enrolment ratio (%) of Tunisia in 1989 to that in 1990?
Offer a very short reply. 0.99. What is the ratio of the Gross enrolment ratio (%) of Kiribati in 1989 to that in 1991?
Keep it short and to the point. 0.97. What is the ratio of the Gross enrolment ratio (%) of Switzerland in 1989 to that in 1991?
Keep it short and to the point. 0.96. What is the ratio of the Gross enrolment ratio (%) of Tunisia in 1989 to that in 1991?
Ensure brevity in your answer.  0.98. What is the ratio of the Gross enrolment ratio (%) in United Kingdom in 1989 to that in 1991?
Your response must be concise. 1.02. What is the ratio of the Gross enrolment ratio (%) in Kiribati in 1989 to that in 1992?
Your response must be concise. 0.97. What is the ratio of the Gross enrolment ratio (%) of Switzerland in 1989 to that in 1992?
Give a very brief answer. 0.96. What is the ratio of the Gross enrolment ratio (%) of Tunisia in 1989 to that in 1992?
Offer a terse response. 0.97. What is the ratio of the Gross enrolment ratio (%) in United Kingdom in 1989 to that in 1992?
Your response must be concise. 1.03. What is the ratio of the Gross enrolment ratio (%) of Kiribati in 1989 to that in 1998?
Offer a terse response. 0.99. What is the ratio of the Gross enrolment ratio (%) in Switzerland in 1989 to that in 1998?
Provide a short and direct response. 0.83. What is the ratio of the Gross enrolment ratio (%) of Tunisia in 1989 to that in 1998?
Provide a short and direct response. 0.95. What is the ratio of the Gross enrolment ratio (%) in United Kingdom in 1989 to that in 1998?
Provide a succinct answer. 1.06. What is the ratio of the Gross enrolment ratio (%) in Kiribati in 1990 to that in 1991?
Offer a terse response. 0.97. What is the ratio of the Gross enrolment ratio (%) of Switzerland in 1990 to that in 1991?
Offer a terse response. 0.99. What is the ratio of the Gross enrolment ratio (%) in United Kingdom in 1990 to that in 1991?
Make the answer very short. 1.01. What is the ratio of the Gross enrolment ratio (%) of Kiribati in 1990 to that in 1992?
Provide a short and direct response. 0.96. What is the ratio of the Gross enrolment ratio (%) in Switzerland in 1990 to that in 1992?
Your response must be concise. 0.98. What is the ratio of the Gross enrolment ratio (%) in Tunisia in 1990 to that in 1992?
Provide a succinct answer. 0.99. What is the ratio of the Gross enrolment ratio (%) in United Kingdom in 1990 to that in 1992?
Offer a very short reply. 1.02. What is the ratio of the Gross enrolment ratio (%) of Kiribati in 1990 to that in 1998?
Keep it short and to the point. 0.98. What is the ratio of the Gross enrolment ratio (%) in Switzerland in 1990 to that in 1998?
Ensure brevity in your answer.  0.85. What is the ratio of the Gross enrolment ratio (%) of Tunisia in 1990 to that in 1998?
Your answer should be very brief. 0.96. What is the ratio of the Gross enrolment ratio (%) in United Kingdom in 1990 to that in 1998?
Ensure brevity in your answer.  1.05. What is the ratio of the Gross enrolment ratio (%) in Tunisia in 1991 to that in 1992?
Offer a terse response. 1. What is the ratio of the Gross enrolment ratio (%) in United Kingdom in 1991 to that in 1992?
Provide a succinct answer. 1.01. What is the ratio of the Gross enrolment ratio (%) in Kiribati in 1991 to that in 1998?
Ensure brevity in your answer.  1.02. What is the ratio of the Gross enrolment ratio (%) of Switzerland in 1991 to that in 1998?
Your response must be concise. 0.86. What is the ratio of the Gross enrolment ratio (%) in Tunisia in 1991 to that in 1998?
Provide a succinct answer. 0.97. What is the ratio of the Gross enrolment ratio (%) of United Kingdom in 1991 to that in 1998?
Offer a very short reply. 1.04. What is the ratio of the Gross enrolment ratio (%) of Kiribati in 1992 to that in 1998?
Your answer should be compact. 1.02. What is the ratio of the Gross enrolment ratio (%) in Switzerland in 1992 to that in 1998?
Your answer should be very brief. 0.87. What is the ratio of the Gross enrolment ratio (%) in Tunisia in 1992 to that in 1998?
Offer a terse response. 0.97. What is the ratio of the Gross enrolment ratio (%) of United Kingdom in 1992 to that in 1998?
Give a very brief answer. 1.03. What is the difference between the highest and the second highest Gross enrolment ratio (%) in Kiribati?
Make the answer very short. 4.3. What is the difference between the highest and the second highest Gross enrolment ratio (%) in Switzerland?
Your response must be concise. 14.04. What is the difference between the highest and the second highest Gross enrolment ratio (%) in Tunisia?
Provide a short and direct response. 0.46. What is the difference between the highest and the second highest Gross enrolment ratio (%) of United Kingdom?
Your answer should be compact. 0.28. What is the difference between the highest and the lowest Gross enrolment ratio (%) in Kiribati?
Your answer should be very brief. 10.35. What is the difference between the highest and the lowest Gross enrolment ratio (%) of Switzerland?
Your response must be concise. 23.65. What is the difference between the highest and the lowest Gross enrolment ratio (%) of Tunisia?
Your response must be concise. 6.37. What is the difference between the highest and the lowest Gross enrolment ratio (%) of United Kingdom?
Make the answer very short. 6.07. 